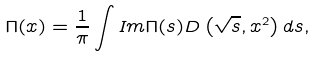<formula> <loc_0><loc_0><loc_500><loc_500>\Pi ( x ) = \frac { 1 } { \pi } \int I m \Pi ( s ) D \left ( \sqrt { s } , x ^ { 2 } \right ) d s ,</formula> 